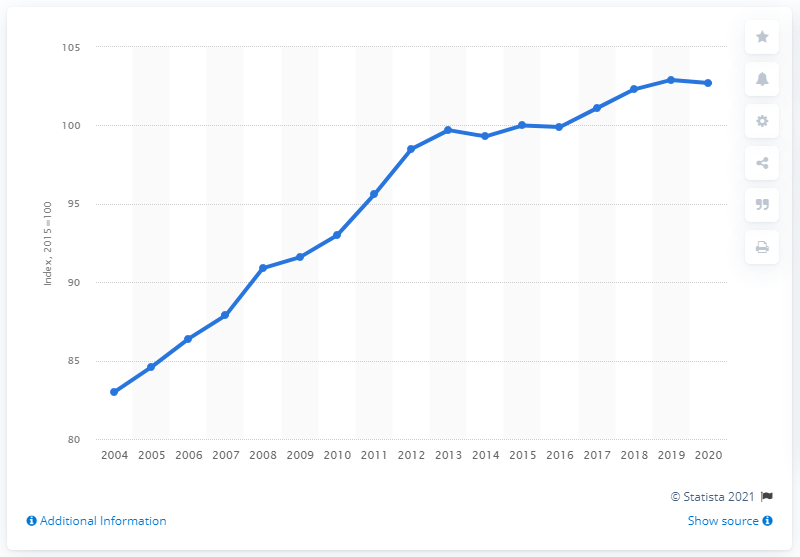Give some essential details in this illustration. The Consumer Price Index in Italy for the year 2020 was 102.7. 